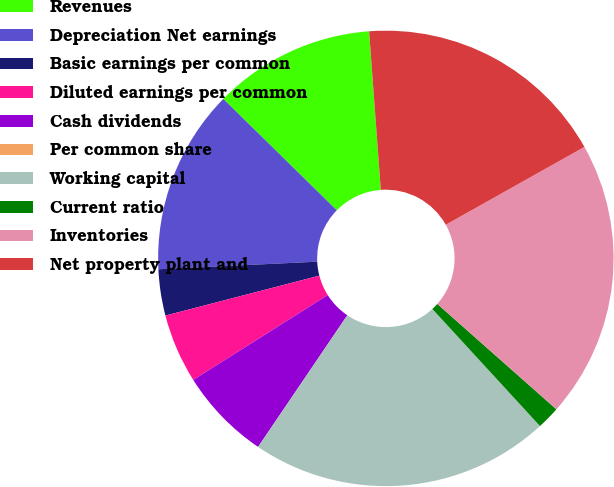<chart> <loc_0><loc_0><loc_500><loc_500><pie_chart><fcel>Revenues<fcel>Depreciation Net earnings<fcel>Basic earnings per common<fcel>Diluted earnings per common<fcel>Cash dividends<fcel>Per common share<fcel>Working capital<fcel>Current ratio<fcel>Inventories<fcel>Net property plant and<nl><fcel>11.48%<fcel>13.11%<fcel>3.28%<fcel>4.92%<fcel>6.56%<fcel>0.0%<fcel>21.31%<fcel>1.64%<fcel>19.67%<fcel>18.03%<nl></chart> 